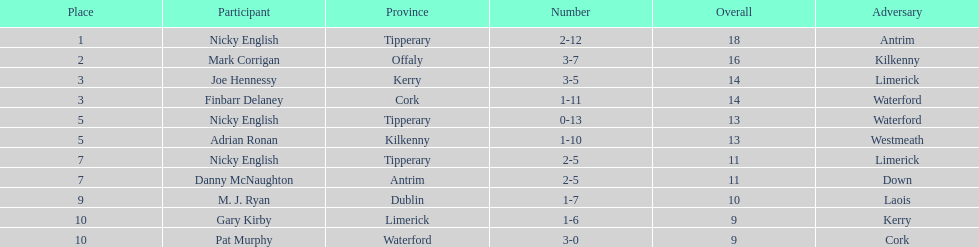What was the combined total of nicky english and mark corrigan? 34. 